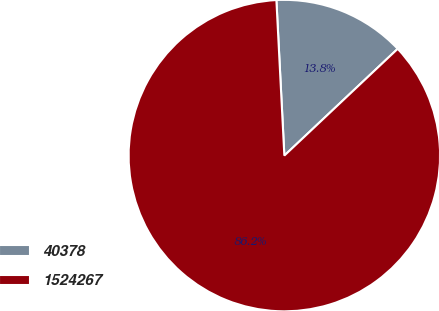Convert chart to OTSL. <chart><loc_0><loc_0><loc_500><loc_500><pie_chart><fcel>40378<fcel>1524267<nl><fcel>13.79%<fcel>86.21%<nl></chart> 